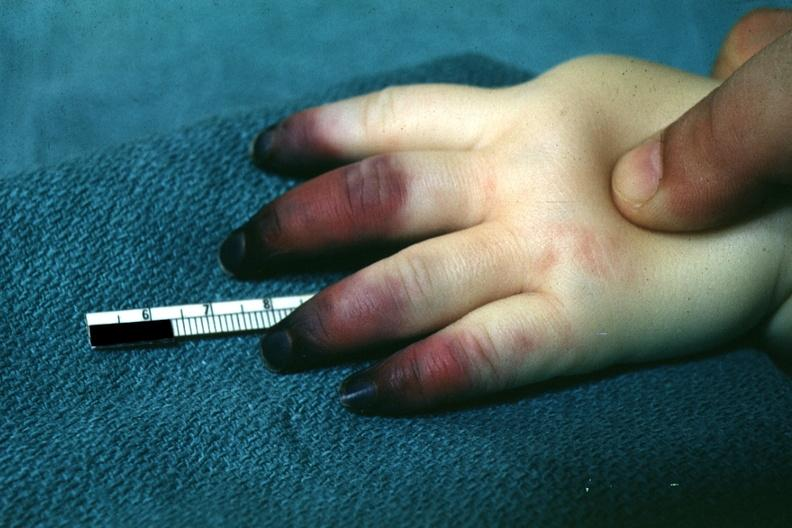s hand present?
Answer the question using a single word or phrase. Yes 